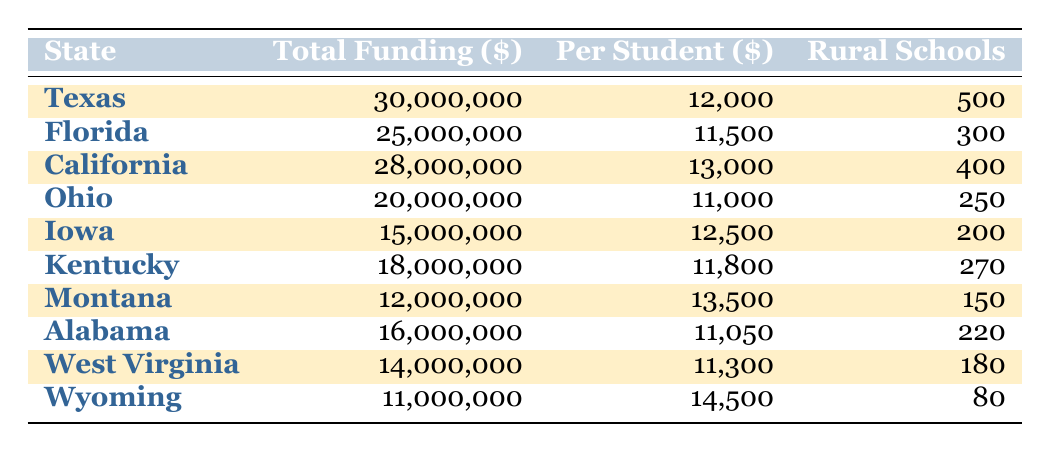What is the total funding allocated to Texas for rural schools in 2023? The table shows that Texas has a total funding amount of 30,000,000 dollars allocated for rural schools.
Answer: 30,000,000 Which state has the highest per-student funding for rural education? California has the highest per-student funding with an amount of 13,000 dollars.
Answer: California How many rural schools are there in Iowa? The table indicates that there are 200 rural schools in Iowa.
Answer: 200 Is the total funding for Florida more than that of Ohio? Florida's total funding is 25,000,000 dollars, while Ohio's is 20,000,000 dollars, making Florida's funding greater, so the answer is yes.
Answer: Yes What is the average total funding of the highlighted states? The highlighted states are Texas, California, Iowa, Montana, and West Virginia, with total funding amounts of 30,000,000, 28,000,000, 15,000,000, 12,000,000, and 14,000,000 respectively. Summing these amounts gives 99,000,000, and there are 5 highlighted states, so the average is 99,000,000 / 5 = 19,800,000.
Answer: 19,800,000 Which state has the least amount of funding allocated for rural education? Wyoming has the least funding with a total of 11,000,000 dollars.
Answer: Wyoming If we add the total funding of Montana and West Virginia, how much funding do they have together? Montana has 12,000,000 and West Virginia has 14,000,000. Adding these amounts together gives 12,000,000 + 14,000,000 = 26,000,000 dollars.
Answer: 26,000,000 Are there more rural schools in Texas than in California? Texas has 500 rural schools, while California has 400 rural schools. Since 500 is greater than 400, the answer is yes.
Answer: Yes What percentage of total funding does Iowa receive compared to the total funding allocated across all states shown in the table? The total funding amounts are Texas (30,000,000), Florida (25,000,000), California (28,000,000), Ohio (20,000,000), Iowa (15,000,000), Kentucky (18,000,000), Montana (12,000,000), Alabama (16,000,000), West Virginia (14,000,000), and Wyoming (11,000,000), which totals to  30+25+28+20+15+18+12+16+14+11 =  299,000,000. Iowa’s amount of 15,000,000 is then (15,000,000 / 299,000,000) * 100 ≈ 5.02%.
Answer: 5.02% How many more rural schools does Texas have compared to West Virginia? Texas has 500 rural schools and West Virginia has 180 rural schools. The difference is 500 - 180 = 320.
Answer: 320 